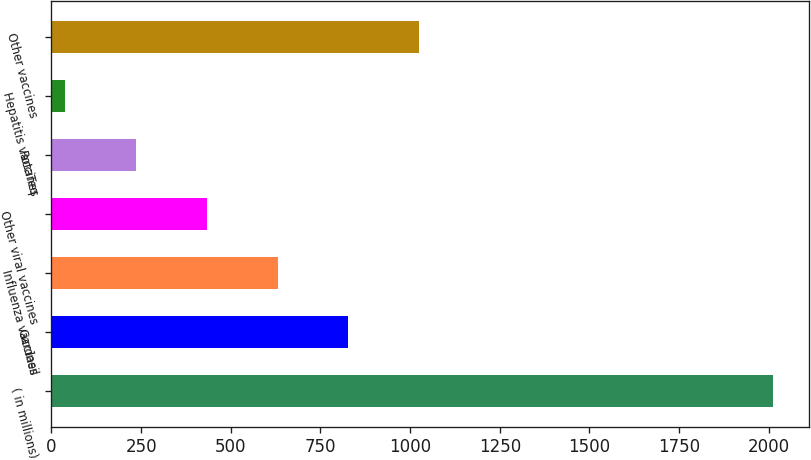Convert chart. <chart><loc_0><loc_0><loc_500><loc_500><bar_chart><fcel>( in millions)<fcel>Gardasil<fcel>Influenza vaccines<fcel>Other viral vaccines<fcel>RotaTeq<fcel>Hepatitis vaccines<fcel>Other vaccines<nl><fcel>2011<fcel>827.8<fcel>630.6<fcel>433.4<fcel>236.2<fcel>39<fcel>1025<nl></chart> 